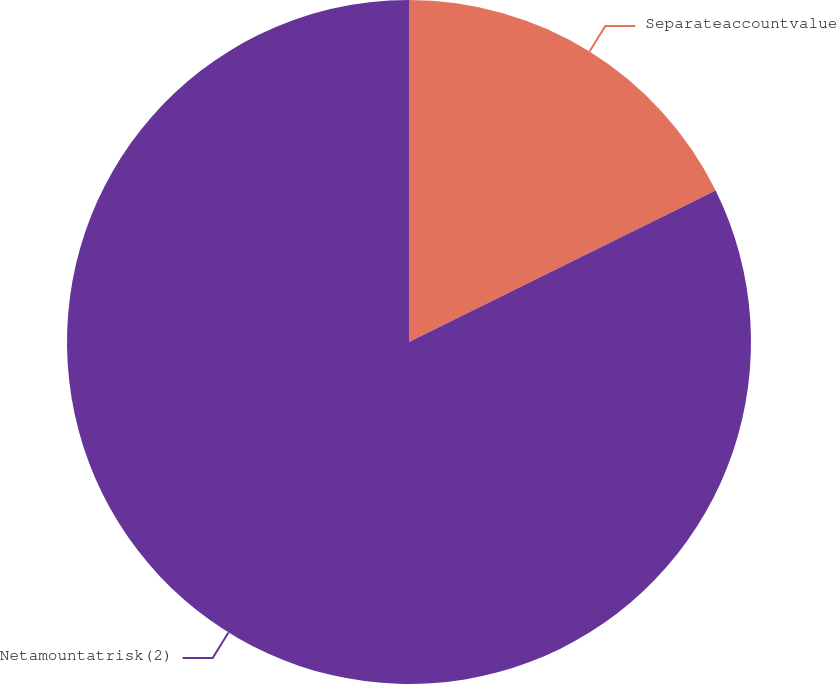<chart> <loc_0><loc_0><loc_500><loc_500><pie_chart><fcel>Separateaccountvalue<fcel>Netamountatrisk(2)<nl><fcel>17.7%<fcel>82.3%<nl></chart> 